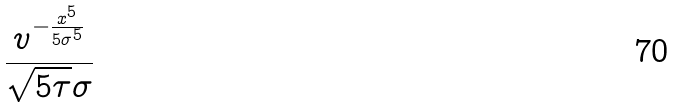Convert formula to latex. <formula><loc_0><loc_0><loc_500><loc_500>\frac { v ^ { - \frac { x ^ { 5 } } { 5 \sigma ^ { 5 } } } } { \sqrt { 5 \tau } \sigma }</formula> 